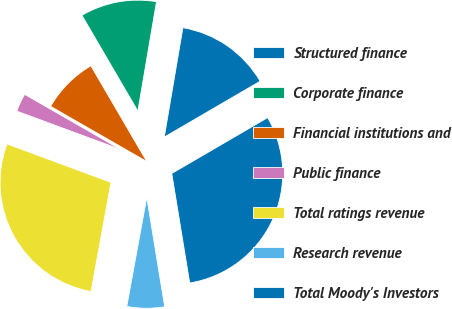Convert chart to OTSL. <chart><loc_0><loc_0><loc_500><loc_500><pie_chart><fcel>Structured finance<fcel>Corporate finance<fcel>Financial institutions and<fcel>Public finance<fcel>Total ratings revenue<fcel>Research revenue<fcel>Total Moody's Investors<nl><fcel>13.92%<fcel>11.1%<fcel>8.29%<fcel>2.66%<fcel>27.75%<fcel>5.47%<fcel>30.81%<nl></chart> 